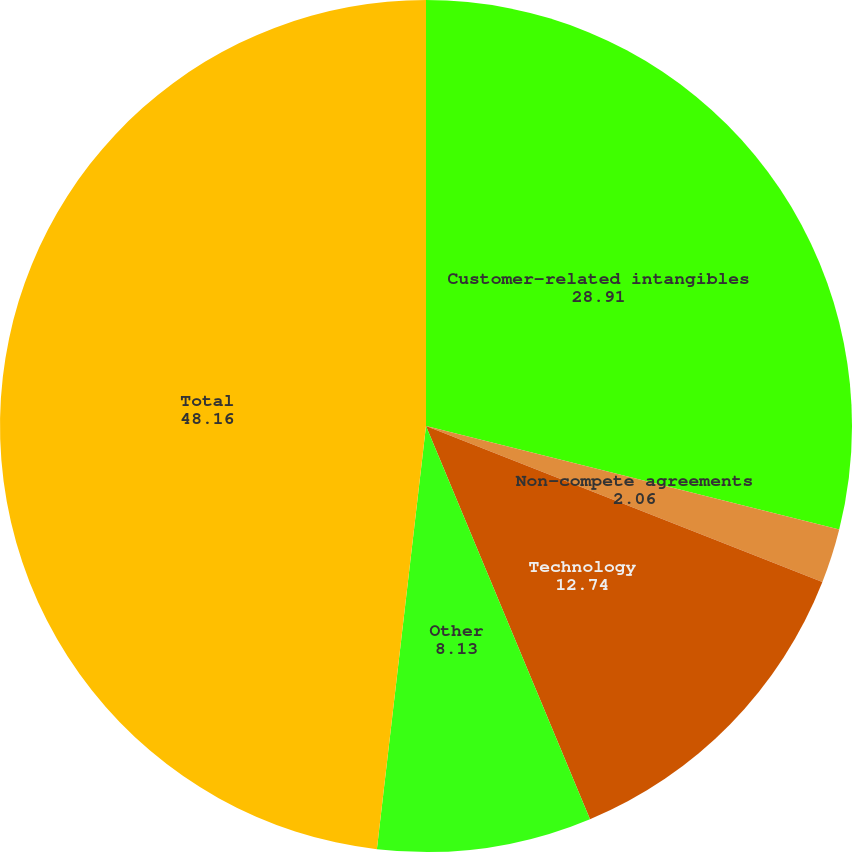Convert chart. <chart><loc_0><loc_0><loc_500><loc_500><pie_chart><fcel>Customer-related intangibles<fcel>Non-compete agreements<fcel>Technology<fcel>Other<fcel>Total<nl><fcel>28.91%<fcel>2.06%<fcel>12.74%<fcel>8.13%<fcel>48.16%<nl></chart> 